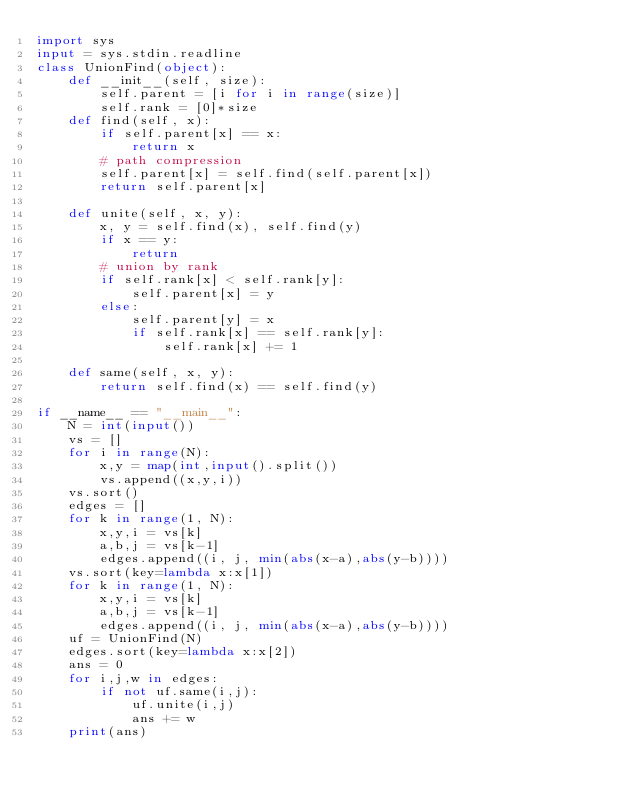<code> <loc_0><loc_0><loc_500><loc_500><_Python_>import sys
input = sys.stdin.readline
class UnionFind(object):
    def __init__(self, size):
        self.parent = [i for i in range(size)]
        self.rank = [0]*size
    def find(self, x):
        if self.parent[x] == x:
            return x
        # path compression
        self.parent[x] = self.find(self.parent[x])
        return self.parent[x]
    
    def unite(self, x, y):
        x, y = self.find(x), self.find(y)
        if x == y:
            return
        # union by rank
        if self.rank[x] < self.rank[y]:
            self.parent[x] = y
        else:
            self.parent[y] = x
            if self.rank[x] == self.rank[y]:
                self.rank[x] += 1
    
    def same(self, x, y):
        return self.find(x) == self.find(y)

if __name__ == "__main__":
    N = int(input())
    vs = []
    for i in range(N):
        x,y = map(int,input().split())
        vs.append((x,y,i))
    vs.sort()
    edges = []
    for k in range(1, N):
        x,y,i = vs[k]
        a,b,j = vs[k-1]
        edges.append((i, j, min(abs(x-a),abs(y-b))))
    vs.sort(key=lambda x:x[1])
    for k in range(1, N):
        x,y,i = vs[k]
        a,b,j = vs[k-1]
        edges.append((i, j, min(abs(x-a),abs(y-b))))
    uf = UnionFind(N)
    edges.sort(key=lambda x:x[2])
    ans = 0
    for i,j,w in edges:
        if not uf.same(i,j):
            uf.unite(i,j)
            ans += w
    print(ans)</code> 